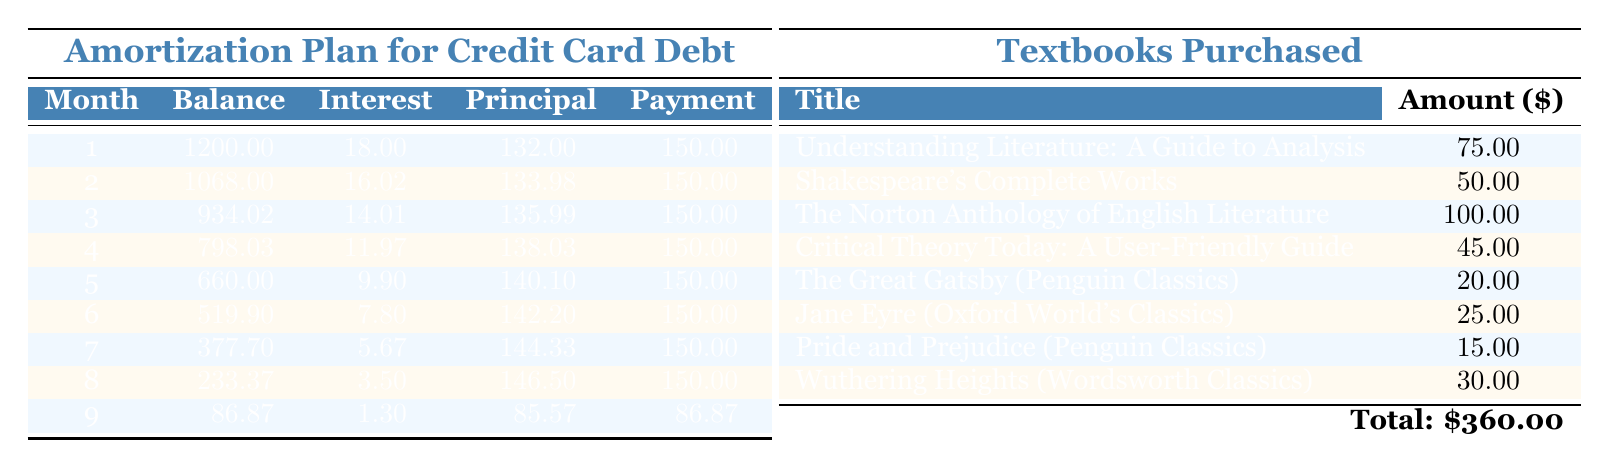What is the initial balance of the credit card debt? The initial balance is clearly stated in the table as 1200.00.
Answer: 1200.00 How much total interest is paid in the first month? The interest for the first month is listed as 18.00 in the table.
Answer: 18.00 What is the balance after the second month? After the second month, the balance is listed as 1068.00.
Answer: 1068.00 How much was spent on textbooks? The table notes that the total amount spent on textbooks is 360.00.
Answer: 360.00 Is the monthly payment sufficient to cover the principal in the first month? The principal payment in the first month is 132.00, which is less than the monthly payment of 150.00. Therefore, the monthly payment is sufficient to cover the principal.
Answer: Yes What is the total amount paid in the first three months? The total paid over the first three months is 150.00 for each month, so (150.00 * 3) = 450.00.
Answer: 450.00 Which month has the highest principal payment and what is its value? The month with the highest principal payment is the sixth month at 142.20.
Answer: 142.20 Is the interest decreasing over the months? Yes, the interest amounts change from 18.00 in the first month to 1.30 in the ninth month, indicating a decline in interest payments.
Answer: Yes After how many months will the balance be fully paid off? According to the table, the balance reaches zero after nine months.
Answer: 9 months What is the average monthly principal payment over the entire payment plan? The principal payments in the first eight months are 132.00, 133.98, 135.99, 138.03, 140.10, 142.20, 144.33, and 146.50. Adding these gives 1,063.13, and dividing by 8 gives an average of 132.89.
Answer: 132.89 